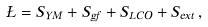<formula> <loc_0><loc_0><loc_500><loc_500>\Sigma = S _ { Y M } + S _ { g f } + S _ { L C O } + S _ { e x t } \, ,</formula> 